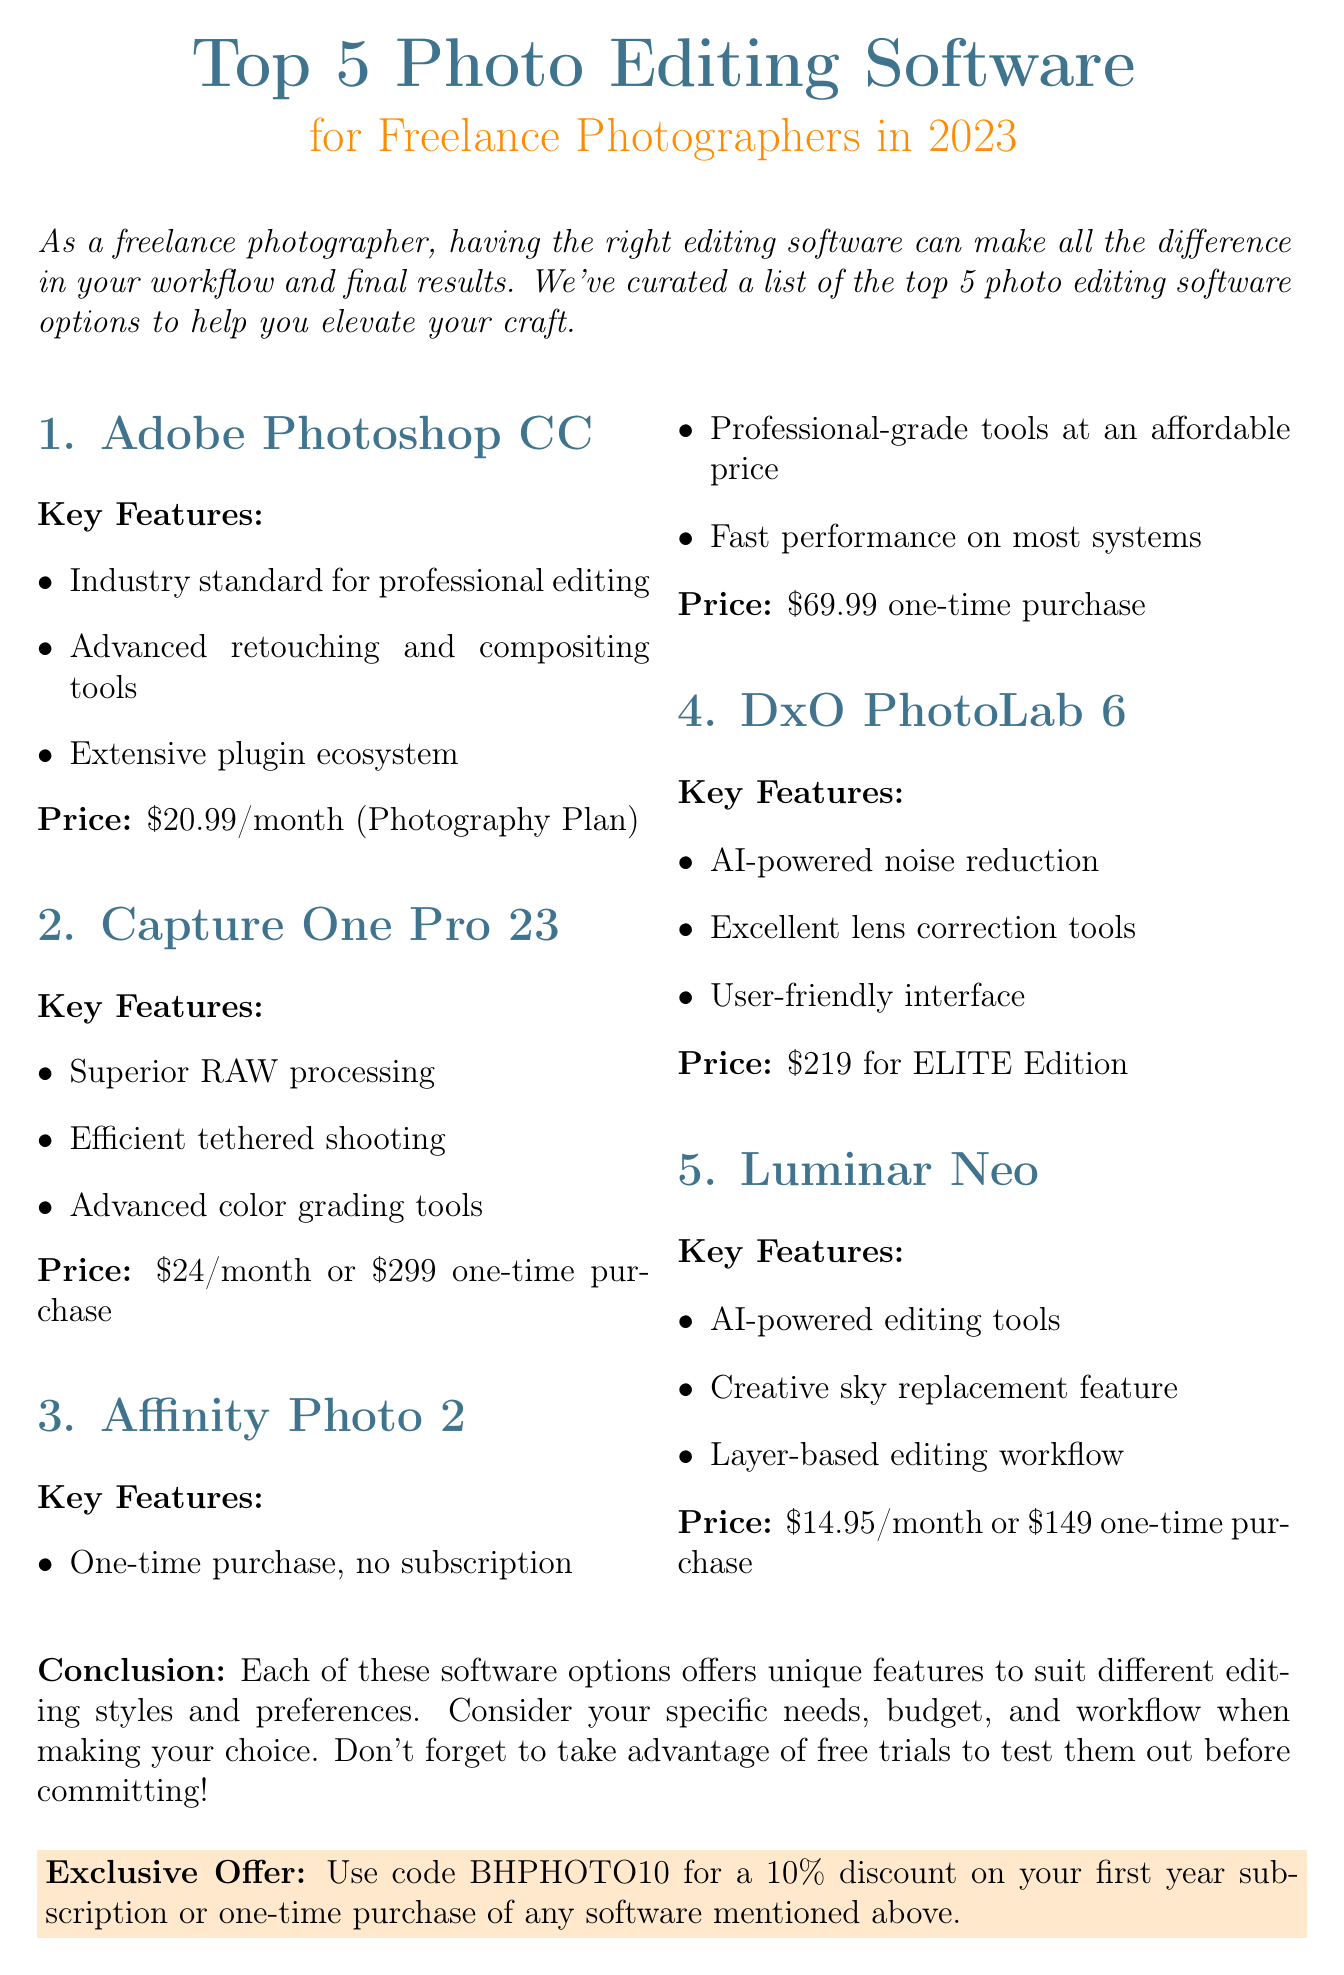What is the subject of the newsletter? The subject of the newsletter is provided at the top of the document, focusing on editing software for photographers.
Answer: Top 5 Photo Editing Software for Freelance Photographers in 2023 What is the price of Adobe Photoshop CC? The price is listed directly after the software's description, providing the cost for subscription plans.
Answer: $20.99/month (Photography Plan) Which software offers a one-time purchase option at an affordable price? This requires inference from the software descriptions regarding pricing models and affordability.
Answer: Affinity Photo 2 What key feature does Luminar Neo offer? The key features of Luminar Neo are mentioned, outlining its capabilities.
Answer: AI-powered editing tools What is the special offer mentioned in the newsletter? This information is included towards the end of the document, highlighting a promotional discount for customers.
Answer: Use code BHPHOTO10 for a 10% discount on your first year subscription or one-time purchase of any software mentioned above How many software options are listed in the newsletter? The number of software options is explicitly stated in the title and confirmed throughout the document.
Answer: 5 What type of user interface does DxO PhotoLab 6 provide? This detail relates to the descriptions provided for each software's features.
Answer: User-friendly interface 